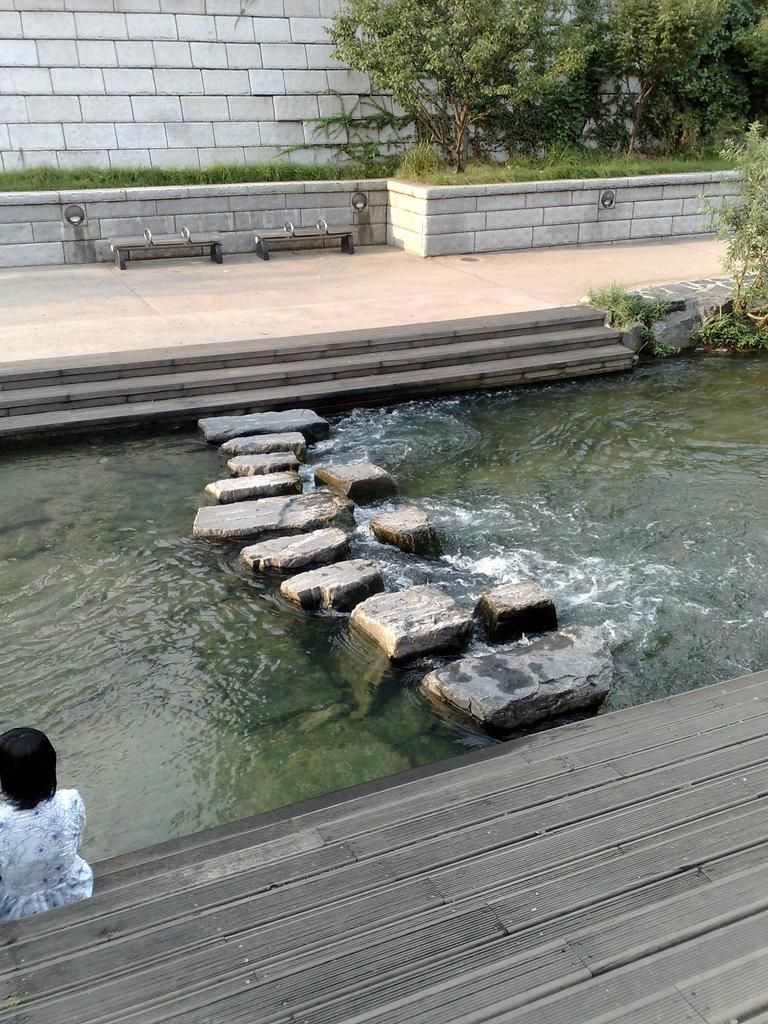What type of structures can be seen in the image? There are walls in the image. What natural elements are present in the image? There are trees, grass, and rocks above the water in the image. What type of seating is available in the image? There are benches in the image. Are there any architectural features in the image? Yes, there are stairs in the image. What is the person in the image doing? There is a person sitting on the floor in the image. What type of linen is being used to cover the trail in the image? There is no trail or linen present in the image. What is the tax rate for the area depicted in the image? The image does not provide any information about tax rates. 